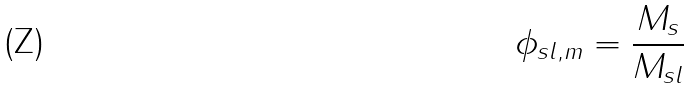Convert formula to latex. <formula><loc_0><loc_0><loc_500><loc_500>\phi _ { s l , m } = \frac { M _ { s } } { M _ { s l } }</formula> 